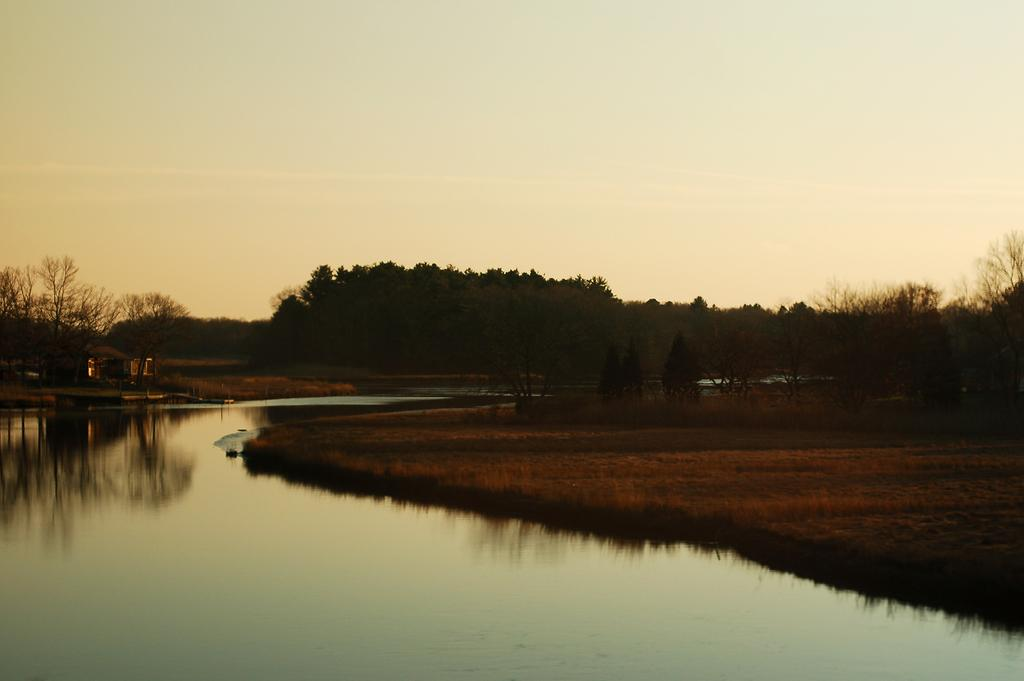What is the main feature in the image? There is a small water pond in the image. What is located next to the water pond? There is a dry grass field beside the water pond. What can be seen in the distance in the image? There are many trees in the background of the image. What type of actor can be seen performing in the bedroom in the image? There is no actor or bedroom present in the image; it features a small water pond, a dry grass field, and trees in the background. 